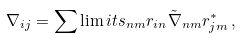Convert formula to latex. <formula><loc_0><loc_0><loc_500><loc_500>\nabla _ { i j } = \sum \lim i t s _ { n m } r _ { i n } \tilde { \nabla } _ { n m } r _ { j m } ^ { * } \, ,</formula> 